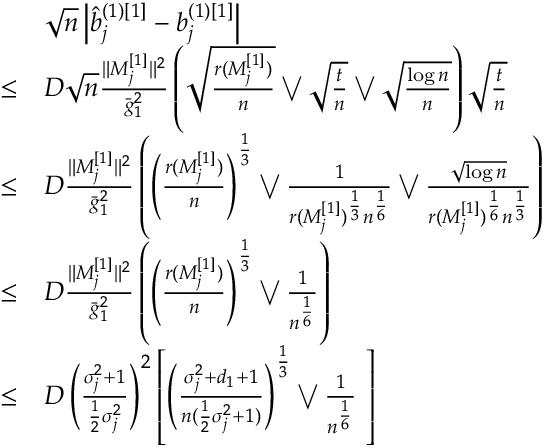<formula> <loc_0><loc_0><loc_500><loc_500>\begin{array} { r l } & { \sqrt { n } \left | \hat { b } _ { j } ^ { ( 1 ) [ 1 ] } - b _ { j } ^ { ( 1 ) [ 1 ] } \right | } \\ { \leq } & { D \sqrt { n } \frac { \| M _ { j } ^ { [ 1 ] } \| ^ { 2 } } { \bar { g } _ { 1 } ^ { 2 } } \left ( \sqrt { \frac { r ( M _ { j } ^ { [ 1 ] } ) } { n } } \bigvee \sqrt { \frac { t } { n } } \bigvee \sqrt { \frac { \log n } { n } } \right ) \sqrt { \frac { t } { n } } } \\ { \leq } & { D \frac { \| M _ { j } ^ { [ 1 ] } \| ^ { 2 } } { \bar { g } _ { 1 } ^ { 2 } } \left ( \left ( \frac { r ( M _ { j } ^ { [ 1 ] } ) } { n } \right ) ^ { \frac { 1 } { 3 } } \bigvee \frac { 1 } { r ( M _ { j } ^ { [ 1 ] } ) ^ { \frac { 1 } { 3 } } n ^ { \frac { 1 } { 6 } } } \bigvee \frac { \sqrt { \log n } } { r ( M _ { j } ^ { [ 1 ] } ) ^ { \frac { 1 } { 6 } } n ^ { \frac { 1 } { 3 } } } \right ) } \\ { \leq } & { D \frac { \| M _ { j } ^ { [ 1 ] } \| ^ { 2 } } { \bar { g } _ { 1 } ^ { 2 } } \left ( \left ( \frac { r ( M _ { j } ^ { [ 1 ] } ) } { n } \right ) ^ { \frac { 1 } { 3 } } \bigvee \frac { 1 } { n ^ { \frac { 1 } { 6 } } } \right ) } \\ { \leq } & { D \left ( \frac { \sigma _ { j } ^ { 2 } + 1 } { \frac { 1 } { 2 } \sigma _ { j } ^ { 2 } } \right ) ^ { 2 } \left [ \left ( \frac { \sigma _ { j } ^ { 2 } + d _ { 1 } + 1 } { n ( \frac { 1 } { 2 } \sigma _ { j } ^ { 2 } + 1 ) } \right ) ^ { \frac { 1 } { 3 } } \bigvee \frac { 1 } { n ^ { \frac { 1 } { 6 } } } \ \right ] } \end{array}</formula> 